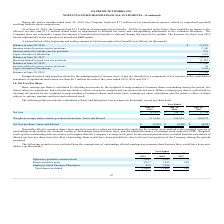According to Extreme Networks's financial document, How were Potentially dilutive common shares from employee incentive plans determined? by applying the treasury stock method to the assumed exercise of outstanding stock options, the assumed vesting of outstanding restricted stock units, and the assumed issuance of common stock under the ESPP. The document states: "ares from employee incentive plans are determined by applying the treasury stock method to the assumed exercise of outstanding stock options, the assu..." Also, Which years does the table provide information for the calculation of basic and diluted net loss per share? The document contains multiple relevant values: 2019, 2018, 2017. From the document: "Balance at June 30, 2017 18,913 During the twelve months ended June 30, 2019, the Company deducted $7.7 million of tax amortization expense related to..." Also, What was the net loss in 2019? According to the financial document, (25,853) (in thousands). The relevant text states: "Net loss $ (25,853) $ (46,792) $ (1,744)..." Also, How many years did the basic and diluted Weighted-average shares used in per share calculation exceed 100,000 thousand? Counting the relevant items in the document: 2019, 2018, 2017, I find 3 instances. The key data points involved are: 2017, 2018, 2019. Also, can you calculate: What was the change in the net loss between 2018 and 2019? Based on the calculation: -25,853-(-46,792), the result is 20939 (in thousands). This is based on the information: "Net loss $ (25,853) $ (46,792) $ (1,744) Net loss $ (25,853) $ (46,792) $ (1,744)..." The key data points involved are: 25,853, 46,792. Also, can you calculate: What was the percentage change in the basic and diluted net loss per share between 2018 and 2019? To answer this question, I need to perform calculations using the financial data. The calculation is: (-0.22+0.40)/-0.40, which equals -45 (percentage). This is based on the information: "Net loss per share - basic and diluted $ (0.22) $ (0.40) $ (0.02) et loss per share - basic and diluted $ (0.22) $ (0.40) $ (0.02)..." The key data points involved are: 0.22, 0.40. 